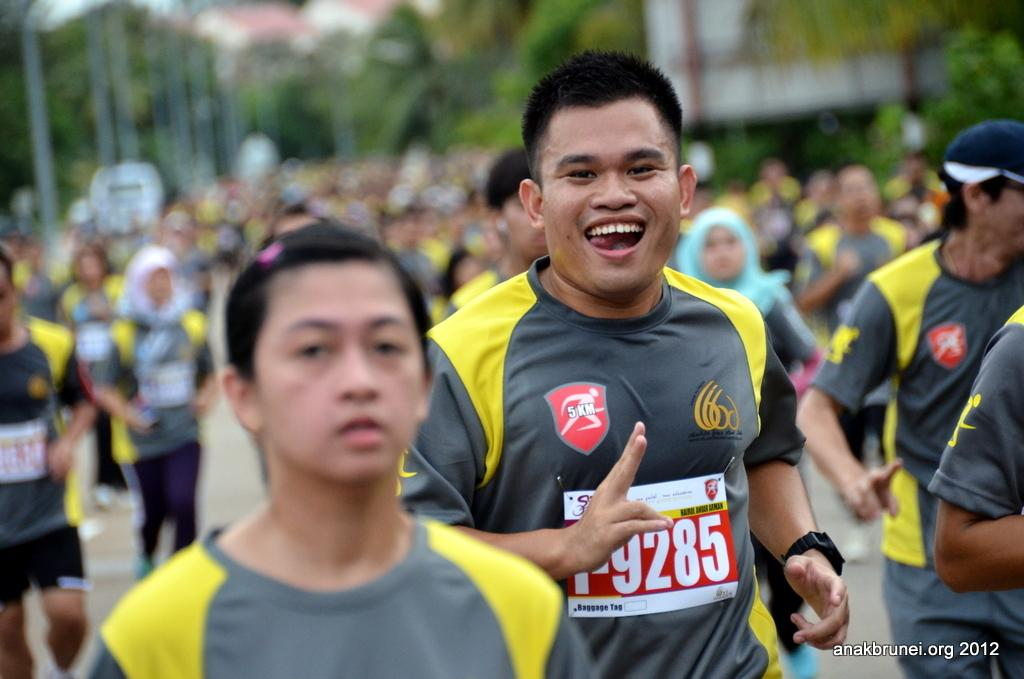What are the people in the image doing? There are many people running in the image. What are the people wearing while running? The people are wearing jerseys. Can you describe the emotions of any person in the image? One person is laughing. What can be seen in the background of the image? There are trees, poles, and buildings in the backdrop of the image. How many friends are visible in the image? The concept of "friends" is not mentioned in the image, so it cannot be determined from the image. What type of badge is the person wearing on their jersey? There is no badge visible on any of the jerseys in the image. 